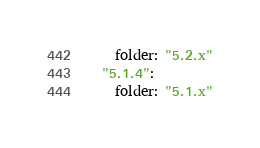<code> <loc_0><loc_0><loc_500><loc_500><_YAML_>    folder: "5.2.x"
  "5.1.4":
    folder: "5.1.x"
</code> 